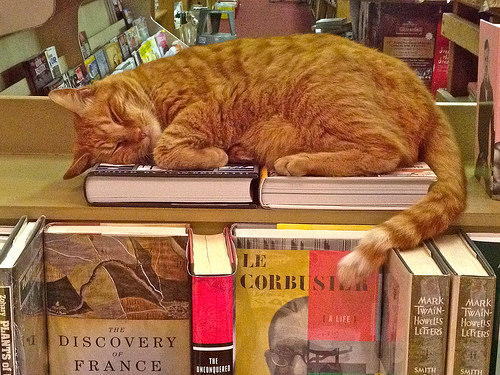<image>
Is there a cat on the book? Yes. Looking at the image, I can see the cat is positioned on top of the book, with the book providing support. Where is the cat in relation to the books? Is it in front of the books? No. The cat is not in front of the books. The spatial positioning shows a different relationship between these objects. 